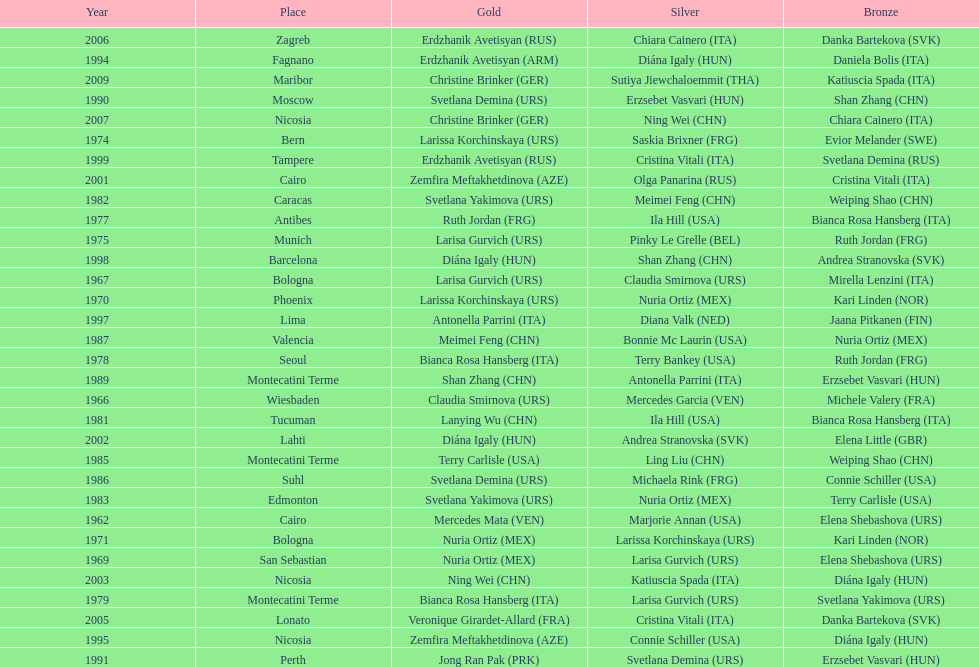What is the total amount of winnings for the united states in gold, silver and bronze? 9. 